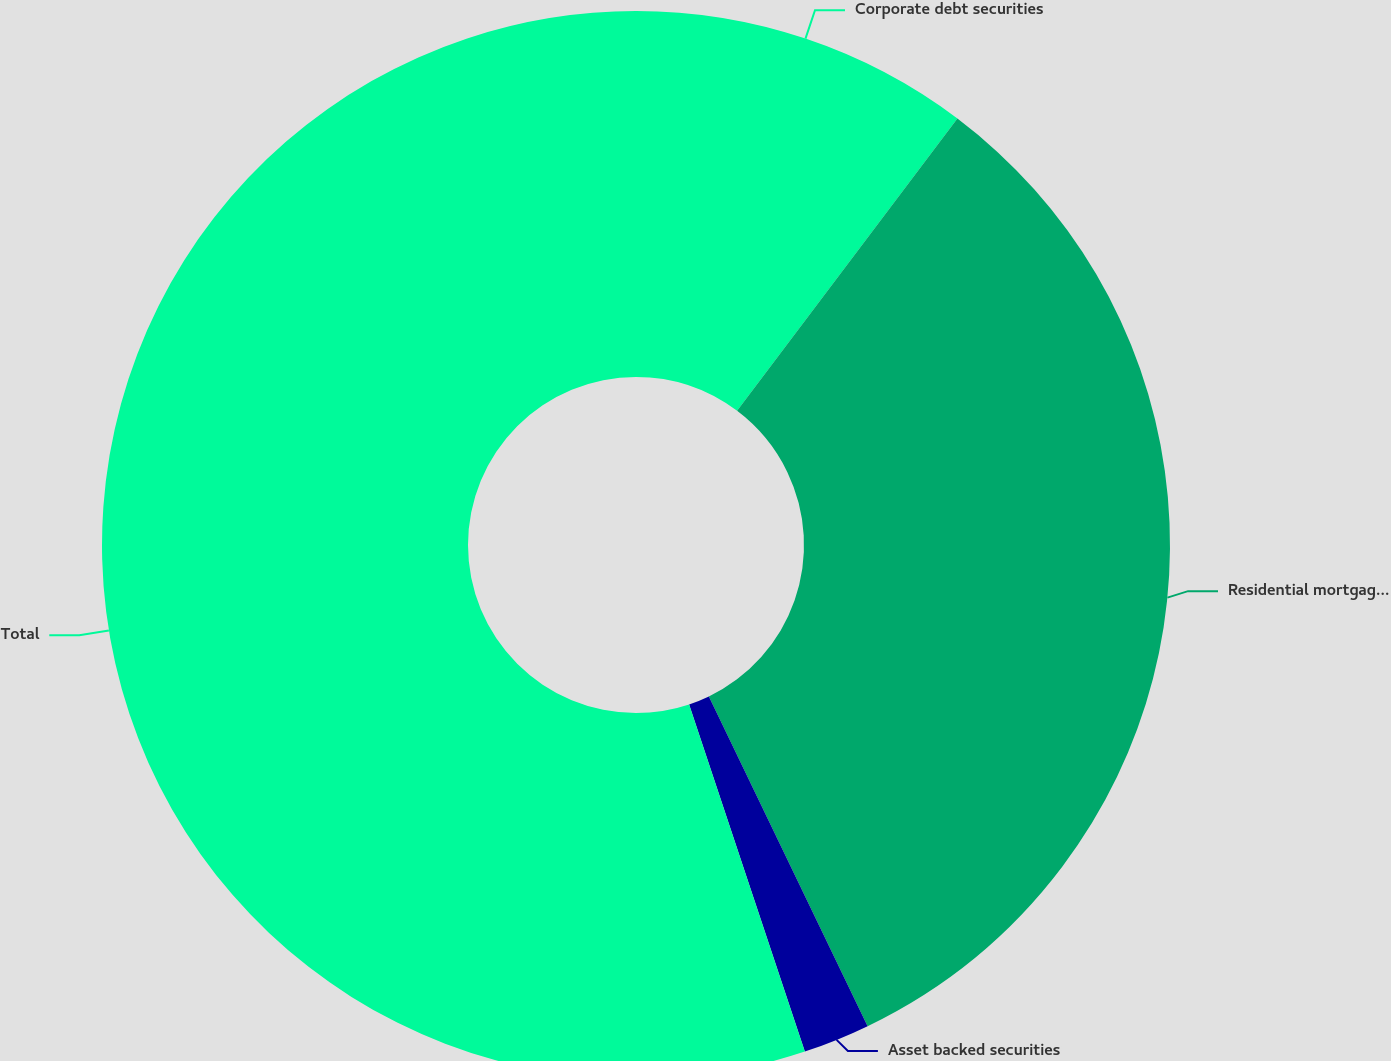Convert chart to OTSL. <chart><loc_0><loc_0><loc_500><loc_500><pie_chart><fcel>Corporate debt securities<fcel>Residential mortgage backed<fcel>Asset backed securities<fcel>Total<nl><fcel>10.28%<fcel>32.58%<fcel>2.02%<fcel>55.12%<nl></chart> 